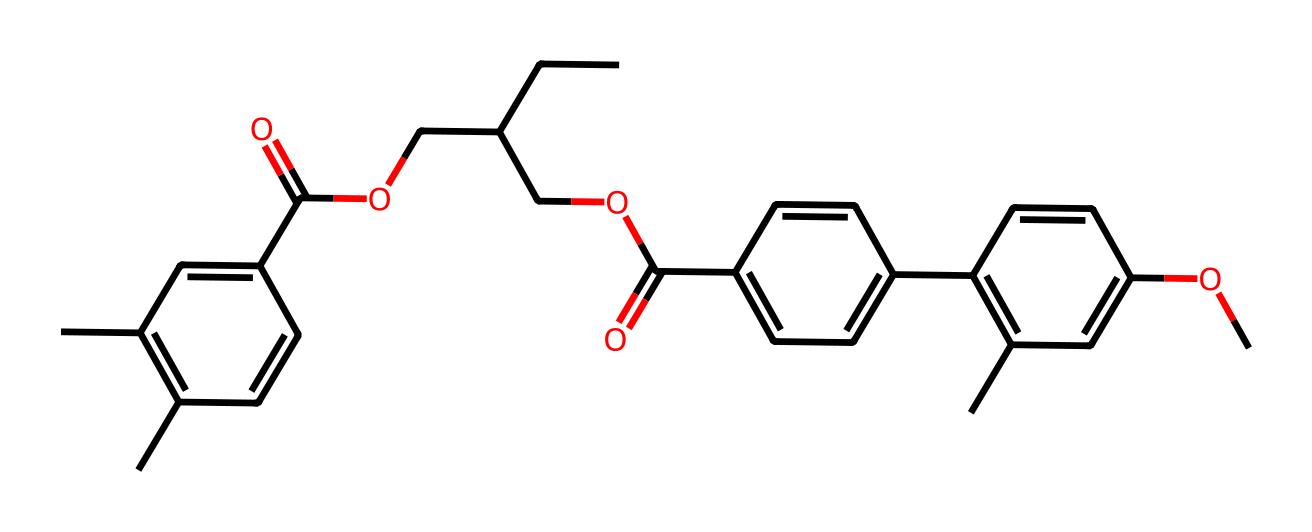What is the total number of carbon atoms in the molecule? By analyzing the SMILES representation, we identify 'C' as carbon atoms. Count the total occurrences of 'C' in the structure; there are 23 carbon atoms present.
Answer: 23 How many double bonds are present in this compound? In the provided SMILES, each 'C' that is directly connected to another 'C' without a 'C' in between can be a double bond. After consideration, there are 5 double bonds in the structure.
Answer: 5 Is this compound a type of ester, acid, or phenol? The presence of a carboxylic acid group 'C(=O)O' and ester groups 'C(=O)OCC' suggests that the compound is classified as an ester.
Answer: ester What functional groups are present in this molecule? By examining the structure, we find a carboxylic acid functional group (C(=O)O), and ester functional groups (C(=O)OCC) indicating the presence of both.
Answer: carboxylic acid and ester What molecular property influences blue light blocking? The presence of conjugated systems in the aromatic rings facilitates the absorption of specific wavelengths, allowing this compound to block blue light.
Answer: conjugated system Does this compound likely absorb UV light? Compounds with conjugated double bonds commonly absorb UV light due to the excitation of electrons within these systems, suggesting that this compound also absorbs UV light.
Answer: yes 